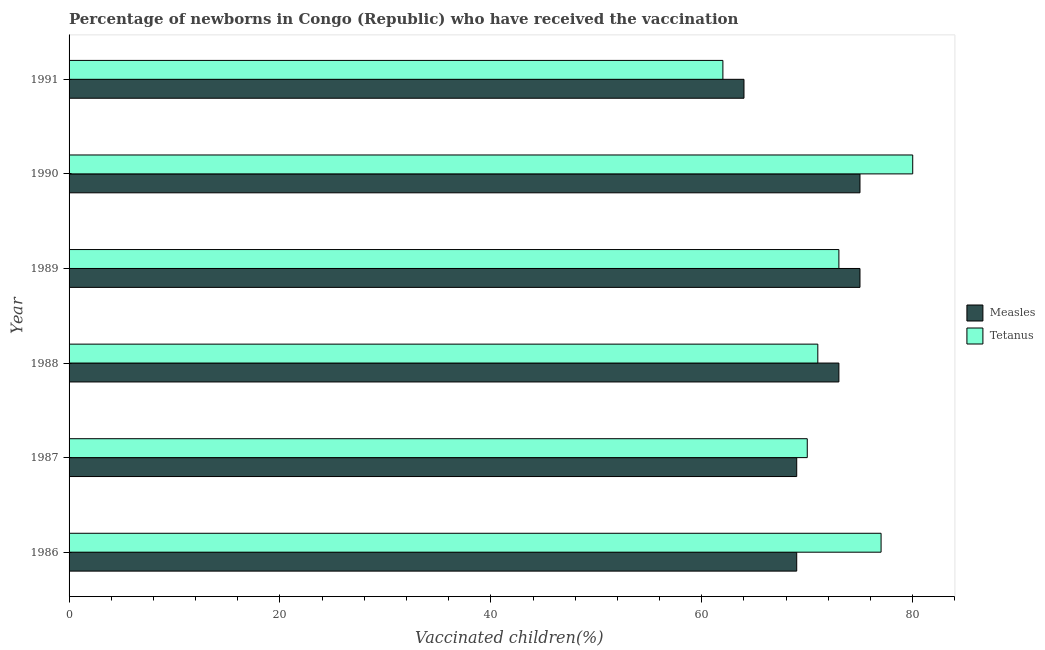How many bars are there on the 2nd tick from the top?
Your answer should be very brief. 2. What is the percentage of newborns who received vaccination for measles in 1991?
Provide a short and direct response. 64. Across all years, what is the maximum percentage of newborns who received vaccination for tetanus?
Keep it short and to the point. 80. Across all years, what is the minimum percentage of newborns who received vaccination for tetanus?
Make the answer very short. 62. In which year was the percentage of newborns who received vaccination for tetanus minimum?
Your answer should be very brief. 1991. What is the total percentage of newborns who received vaccination for tetanus in the graph?
Your response must be concise. 433. What is the difference between the percentage of newborns who received vaccination for measles in 1987 and that in 1991?
Give a very brief answer. 5. What is the difference between the percentage of newborns who received vaccination for measles in 1986 and the percentage of newborns who received vaccination for tetanus in 1990?
Make the answer very short. -11. What is the average percentage of newborns who received vaccination for tetanus per year?
Keep it short and to the point. 72.17. In the year 1988, what is the difference between the percentage of newborns who received vaccination for measles and percentage of newborns who received vaccination for tetanus?
Your response must be concise. 2. What is the ratio of the percentage of newborns who received vaccination for tetanus in 1987 to that in 1989?
Keep it short and to the point. 0.96. Is the percentage of newborns who received vaccination for measles in 1988 less than that in 1990?
Your answer should be very brief. Yes. Is the difference between the percentage of newborns who received vaccination for tetanus in 1987 and 1988 greater than the difference between the percentage of newborns who received vaccination for measles in 1987 and 1988?
Give a very brief answer. Yes. What is the difference between the highest and the second highest percentage of newborns who received vaccination for measles?
Keep it short and to the point. 0. What is the difference between the highest and the lowest percentage of newborns who received vaccination for tetanus?
Your answer should be very brief. 18. Is the sum of the percentage of newborns who received vaccination for measles in 1986 and 1988 greater than the maximum percentage of newborns who received vaccination for tetanus across all years?
Offer a terse response. Yes. What does the 1st bar from the top in 1988 represents?
Your response must be concise. Tetanus. What does the 2nd bar from the bottom in 1991 represents?
Ensure brevity in your answer.  Tetanus. How many bars are there?
Your answer should be very brief. 12. Are all the bars in the graph horizontal?
Offer a terse response. Yes. Are the values on the major ticks of X-axis written in scientific E-notation?
Your answer should be compact. No. Does the graph contain any zero values?
Your response must be concise. No. Does the graph contain grids?
Provide a succinct answer. No. What is the title of the graph?
Keep it short and to the point. Percentage of newborns in Congo (Republic) who have received the vaccination. Does "Diarrhea" appear as one of the legend labels in the graph?
Provide a succinct answer. No. What is the label or title of the X-axis?
Provide a short and direct response. Vaccinated children(%)
. What is the Vaccinated children(%)
 in Tetanus in 1986?
Provide a short and direct response. 77. What is the Vaccinated children(%)
 in Measles in 1989?
Make the answer very short. 75. What is the Vaccinated children(%)
 in Measles in 1990?
Your response must be concise. 75. What is the Vaccinated children(%)
 in Tetanus in 1990?
Your answer should be very brief. 80. What is the Vaccinated children(%)
 in Tetanus in 1991?
Your answer should be compact. 62. Across all years, what is the maximum Vaccinated children(%)
 of Measles?
Make the answer very short. 75. Across all years, what is the maximum Vaccinated children(%)
 of Tetanus?
Provide a succinct answer. 80. What is the total Vaccinated children(%)
 of Measles in the graph?
Give a very brief answer. 425. What is the total Vaccinated children(%)
 of Tetanus in the graph?
Give a very brief answer. 433. What is the difference between the Vaccinated children(%)
 in Measles in 1986 and that in 1987?
Provide a short and direct response. 0. What is the difference between the Vaccinated children(%)
 in Tetanus in 1986 and that in 1988?
Your answer should be very brief. 6. What is the difference between the Vaccinated children(%)
 in Tetanus in 1986 and that in 1989?
Your answer should be very brief. 4. What is the difference between the Vaccinated children(%)
 in Tetanus in 1986 and that in 1990?
Provide a succinct answer. -3. What is the difference between the Vaccinated children(%)
 in Tetanus in 1986 and that in 1991?
Offer a very short reply. 15. What is the difference between the Vaccinated children(%)
 of Tetanus in 1987 and that in 1988?
Provide a short and direct response. -1. What is the difference between the Vaccinated children(%)
 in Measles in 1987 and that in 1989?
Provide a short and direct response. -6. What is the difference between the Vaccinated children(%)
 of Tetanus in 1987 and that in 1989?
Provide a short and direct response. -3. What is the difference between the Vaccinated children(%)
 of Measles in 1987 and that in 1991?
Make the answer very short. 5. What is the difference between the Vaccinated children(%)
 in Measles in 1988 and that in 1989?
Your answer should be compact. -2. What is the difference between the Vaccinated children(%)
 in Measles in 1988 and that in 1990?
Your answer should be very brief. -2. What is the difference between the Vaccinated children(%)
 of Measles in 1988 and that in 1991?
Provide a succinct answer. 9. What is the difference between the Vaccinated children(%)
 of Measles in 1989 and that in 1990?
Give a very brief answer. 0. What is the difference between the Vaccinated children(%)
 of Tetanus in 1989 and that in 1990?
Offer a very short reply. -7. What is the difference between the Vaccinated children(%)
 of Measles in 1989 and that in 1991?
Ensure brevity in your answer.  11. What is the difference between the Vaccinated children(%)
 in Tetanus in 1989 and that in 1991?
Ensure brevity in your answer.  11. What is the difference between the Vaccinated children(%)
 of Measles in 1990 and that in 1991?
Provide a succinct answer. 11. What is the difference between the Vaccinated children(%)
 of Tetanus in 1990 and that in 1991?
Your response must be concise. 18. What is the difference between the Vaccinated children(%)
 of Measles in 1986 and the Vaccinated children(%)
 of Tetanus in 1988?
Your answer should be very brief. -2. What is the difference between the Vaccinated children(%)
 of Measles in 1986 and the Vaccinated children(%)
 of Tetanus in 1989?
Give a very brief answer. -4. What is the difference between the Vaccinated children(%)
 in Measles in 1986 and the Vaccinated children(%)
 in Tetanus in 1990?
Your answer should be very brief. -11. What is the difference between the Vaccinated children(%)
 in Measles in 1986 and the Vaccinated children(%)
 in Tetanus in 1991?
Provide a succinct answer. 7. What is the difference between the Vaccinated children(%)
 in Measles in 1987 and the Vaccinated children(%)
 in Tetanus in 1989?
Provide a succinct answer. -4. What is the difference between the Vaccinated children(%)
 in Measles in 1987 and the Vaccinated children(%)
 in Tetanus in 1990?
Your response must be concise. -11. What is the difference between the Vaccinated children(%)
 in Measles in 1987 and the Vaccinated children(%)
 in Tetanus in 1991?
Offer a very short reply. 7. What is the difference between the Vaccinated children(%)
 in Measles in 1988 and the Vaccinated children(%)
 in Tetanus in 1989?
Provide a succinct answer. 0. What is the difference between the Vaccinated children(%)
 of Measles in 1988 and the Vaccinated children(%)
 of Tetanus in 1990?
Offer a very short reply. -7. What is the difference between the Vaccinated children(%)
 in Measles in 1988 and the Vaccinated children(%)
 in Tetanus in 1991?
Offer a very short reply. 11. What is the difference between the Vaccinated children(%)
 in Measles in 1989 and the Vaccinated children(%)
 in Tetanus in 1990?
Keep it short and to the point. -5. What is the difference between the Vaccinated children(%)
 in Measles in 1990 and the Vaccinated children(%)
 in Tetanus in 1991?
Keep it short and to the point. 13. What is the average Vaccinated children(%)
 in Measles per year?
Give a very brief answer. 70.83. What is the average Vaccinated children(%)
 in Tetanus per year?
Offer a terse response. 72.17. In the year 1986, what is the difference between the Vaccinated children(%)
 in Measles and Vaccinated children(%)
 in Tetanus?
Your answer should be compact. -8. In the year 1987, what is the difference between the Vaccinated children(%)
 of Measles and Vaccinated children(%)
 of Tetanus?
Your answer should be very brief. -1. In the year 1989, what is the difference between the Vaccinated children(%)
 in Measles and Vaccinated children(%)
 in Tetanus?
Your answer should be compact. 2. What is the ratio of the Vaccinated children(%)
 of Measles in 1986 to that in 1987?
Offer a terse response. 1. What is the ratio of the Vaccinated children(%)
 in Tetanus in 1986 to that in 1987?
Offer a terse response. 1.1. What is the ratio of the Vaccinated children(%)
 in Measles in 1986 to that in 1988?
Make the answer very short. 0.95. What is the ratio of the Vaccinated children(%)
 of Tetanus in 1986 to that in 1988?
Provide a succinct answer. 1.08. What is the ratio of the Vaccinated children(%)
 of Measles in 1986 to that in 1989?
Offer a terse response. 0.92. What is the ratio of the Vaccinated children(%)
 of Tetanus in 1986 to that in 1989?
Give a very brief answer. 1.05. What is the ratio of the Vaccinated children(%)
 of Tetanus in 1986 to that in 1990?
Provide a succinct answer. 0.96. What is the ratio of the Vaccinated children(%)
 in Measles in 1986 to that in 1991?
Your answer should be compact. 1.08. What is the ratio of the Vaccinated children(%)
 in Tetanus in 1986 to that in 1991?
Your answer should be very brief. 1.24. What is the ratio of the Vaccinated children(%)
 of Measles in 1987 to that in 1988?
Your response must be concise. 0.95. What is the ratio of the Vaccinated children(%)
 in Tetanus in 1987 to that in 1988?
Your response must be concise. 0.99. What is the ratio of the Vaccinated children(%)
 of Measles in 1987 to that in 1989?
Your answer should be very brief. 0.92. What is the ratio of the Vaccinated children(%)
 in Tetanus in 1987 to that in 1989?
Keep it short and to the point. 0.96. What is the ratio of the Vaccinated children(%)
 of Measles in 1987 to that in 1990?
Offer a terse response. 0.92. What is the ratio of the Vaccinated children(%)
 in Tetanus in 1987 to that in 1990?
Provide a succinct answer. 0.88. What is the ratio of the Vaccinated children(%)
 in Measles in 1987 to that in 1991?
Offer a terse response. 1.08. What is the ratio of the Vaccinated children(%)
 of Tetanus in 1987 to that in 1991?
Your answer should be very brief. 1.13. What is the ratio of the Vaccinated children(%)
 in Measles in 1988 to that in 1989?
Your response must be concise. 0.97. What is the ratio of the Vaccinated children(%)
 in Tetanus in 1988 to that in 1989?
Keep it short and to the point. 0.97. What is the ratio of the Vaccinated children(%)
 in Measles in 1988 to that in 1990?
Ensure brevity in your answer.  0.97. What is the ratio of the Vaccinated children(%)
 of Tetanus in 1988 to that in 1990?
Provide a succinct answer. 0.89. What is the ratio of the Vaccinated children(%)
 in Measles in 1988 to that in 1991?
Ensure brevity in your answer.  1.14. What is the ratio of the Vaccinated children(%)
 of Tetanus in 1988 to that in 1991?
Your response must be concise. 1.15. What is the ratio of the Vaccinated children(%)
 in Measles in 1989 to that in 1990?
Your answer should be compact. 1. What is the ratio of the Vaccinated children(%)
 in Tetanus in 1989 to that in 1990?
Your response must be concise. 0.91. What is the ratio of the Vaccinated children(%)
 of Measles in 1989 to that in 1991?
Ensure brevity in your answer.  1.17. What is the ratio of the Vaccinated children(%)
 of Tetanus in 1989 to that in 1991?
Your answer should be compact. 1.18. What is the ratio of the Vaccinated children(%)
 in Measles in 1990 to that in 1991?
Your answer should be compact. 1.17. What is the ratio of the Vaccinated children(%)
 of Tetanus in 1990 to that in 1991?
Make the answer very short. 1.29. What is the difference between the highest and the lowest Vaccinated children(%)
 of Measles?
Your answer should be compact. 11. What is the difference between the highest and the lowest Vaccinated children(%)
 of Tetanus?
Your answer should be compact. 18. 